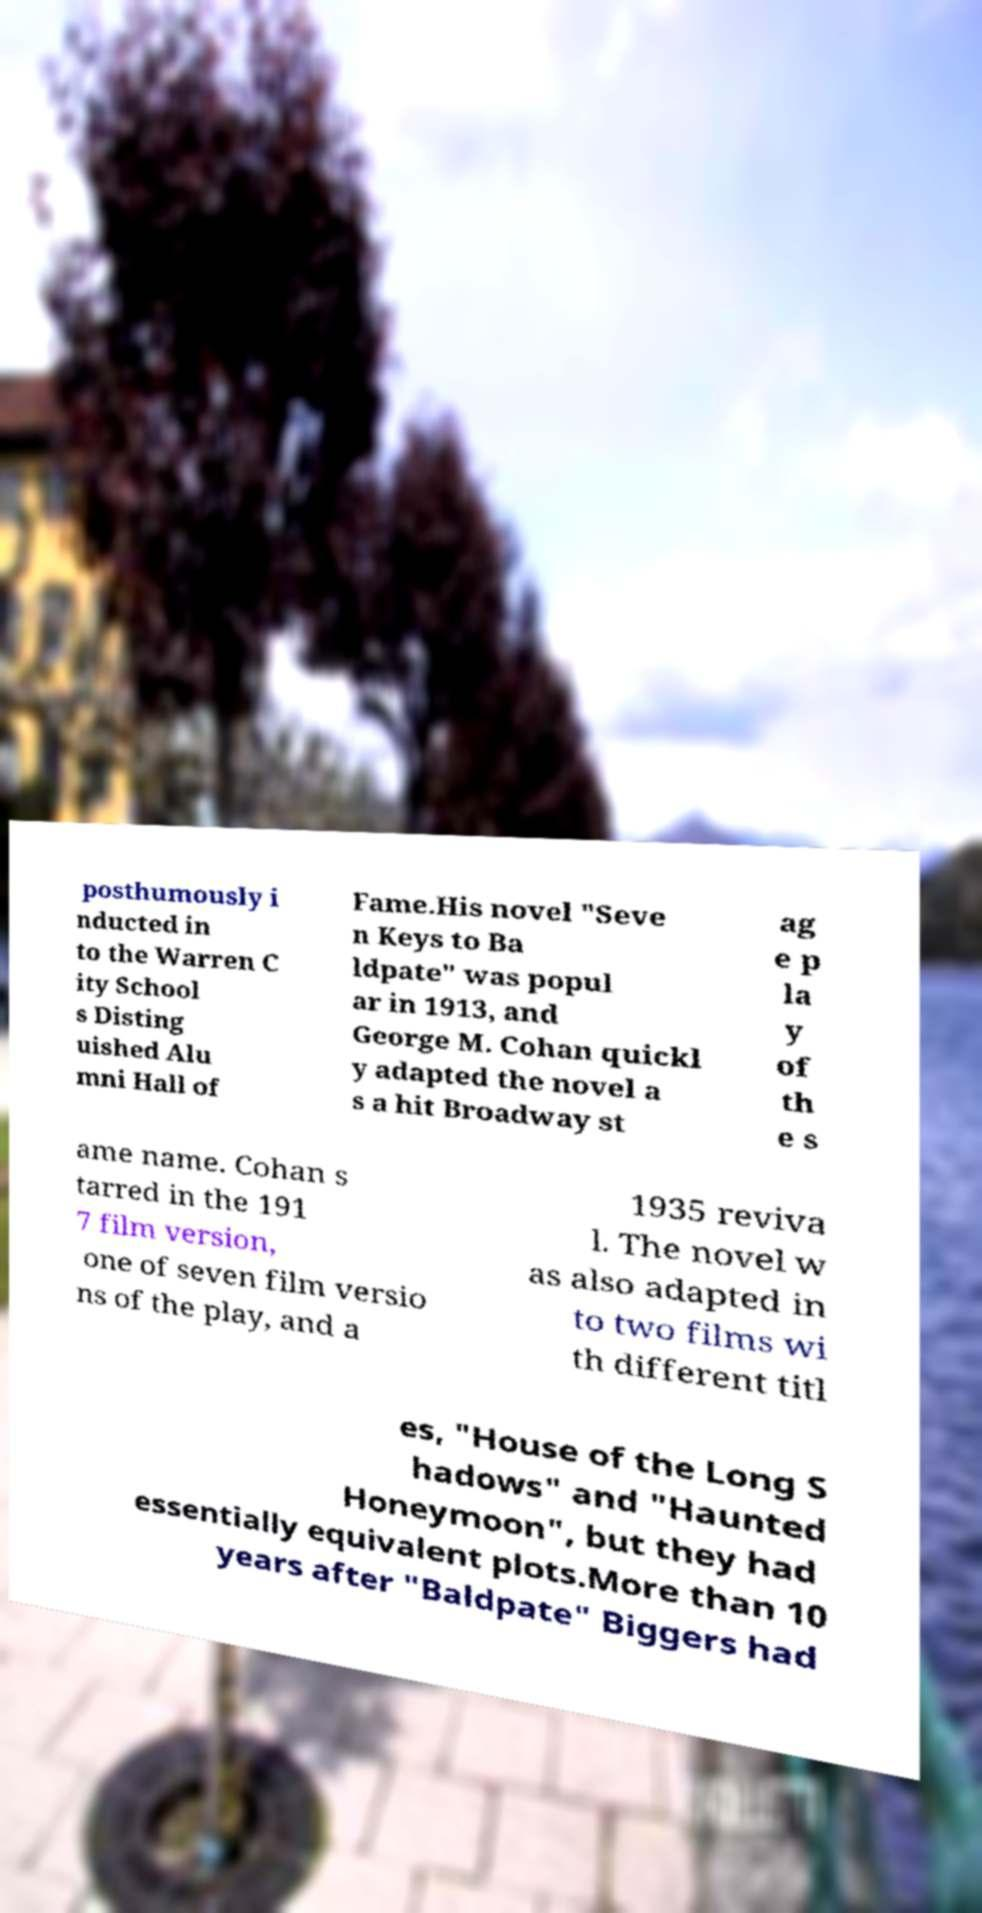Please read and relay the text visible in this image. What does it say? posthumously i nducted in to the Warren C ity School s Disting uished Alu mni Hall of Fame.His novel "Seve n Keys to Ba ldpate" was popul ar in 1913, and George M. Cohan quickl y adapted the novel a s a hit Broadway st ag e p la y of th e s ame name. Cohan s tarred in the 191 7 film version, one of seven film versio ns of the play, and a 1935 reviva l. The novel w as also adapted in to two films wi th different titl es, "House of the Long S hadows" and "Haunted Honeymoon", but they had essentially equivalent plots.More than 10 years after "Baldpate" Biggers had 